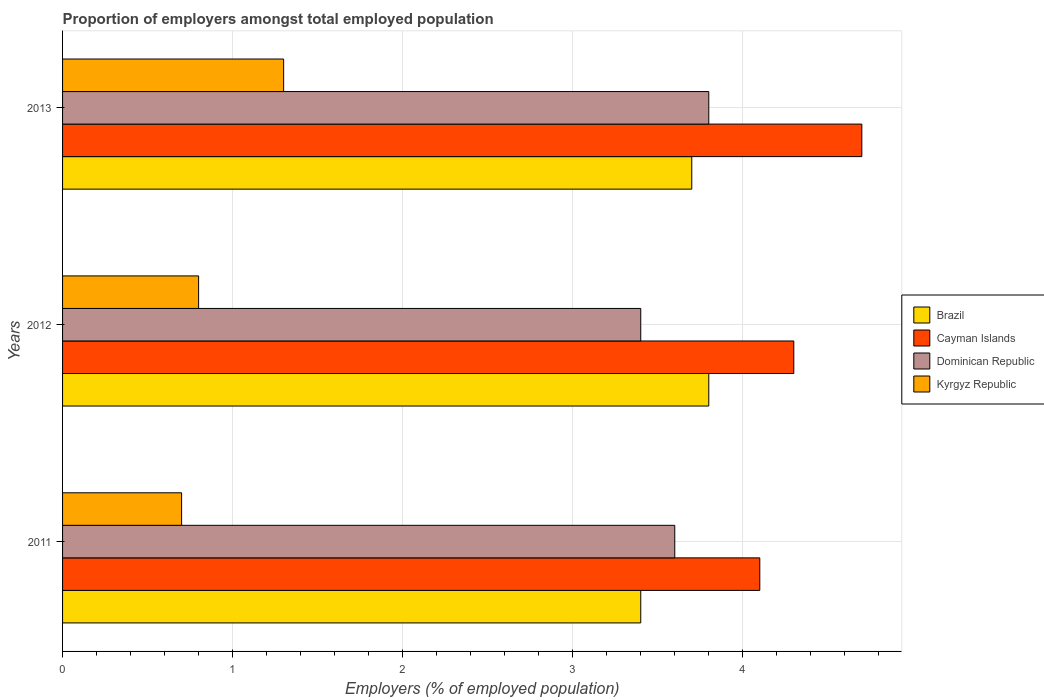How many bars are there on the 2nd tick from the top?
Keep it short and to the point. 4. How many bars are there on the 1st tick from the bottom?
Provide a succinct answer. 4. What is the label of the 1st group of bars from the top?
Your answer should be very brief. 2013. What is the proportion of employers in Dominican Republic in 2012?
Your answer should be very brief. 3.4. Across all years, what is the maximum proportion of employers in Brazil?
Your answer should be very brief. 3.8. Across all years, what is the minimum proportion of employers in Kyrgyz Republic?
Provide a succinct answer. 0.7. In which year was the proportion of employers in Cayman Islands maximum?
Make the answer very short. 2013. What is the total proportion of employers in Dominican Republic in the graph?
Your answer should be compact. 10.8. What is the difference between the proportion of employers in Dominican Republic in 2012 and that in 2013?
Offer a very short reply. -0.4. What is the difference between the proportion of employers in Brazil in 2011 and the proportion of employers in Cayman Islands in 2013?
Offer a terse response. -1.3. What is the average proportion of employers in Cayman Islands per year?
Ensure brevity in your answer.  4.37. In the year 2013, what is the difference between the proportion of employers in Brazil and proportion of employers in Kyrgyz Republic?
Your response must be concise. 2.4. What is the ratio of the proportion of employers in Kyrgyz Republic in 2011 to that in 2013?
Offer a terse response. 0.54. Is the difference between the proportion of employers in Brazil in 2011 and 2013 greater than the difference between the proportion of employers in Kyrgyz Republic in 2011 and 2013?
Offer a terse response. Yes. What is the difference between the highest and the second highest proportion of employers in Kyrgyz Republic?
Provide a succinct answer. 0.5. What is the difference between the highest and the lowest proportion of employers in Dominican Republic?
Keep it short and to the point. 0.4. In how many years, is the proportion of employers in Brazil greater than the average proportion of employers in Brazil taken over all years?
Offer a terse response. 2. What does the 3rd bar from the top in 2012 represents?
Ensure brevity in your answer.  Cayman Islands. What does the 2nd bar from the bottom in 2013 represents?
Your answer should be very brief. Cayman Islands. Is it the case that in every year, the sum of the proportion of employers in Dominican Republic and proportion of employers in Brazil is greater than the proportion of employers in Kyrgyz Republic?
Your answer should be very brief. Yes. Are all the bars in the graph horizontal?
Offer a very short reply. Yes. Are the values on the major ticks of X-axis written in scientific E-notation?
Your answer should be compact. No. Does the graph contain grids?
Make the answer very short. Yes. How many legend labels are there?
Provide a short and direct response. 4. How are the legend labels stacked?
Keep it short and to the point. Vertical. What is the title of the graph?
Your response must be concise. Proportion of employers amongst total employed population. Does "Monaco" appear as one of the legend labels in the graph?
Your answer should be very brief. No. What is the label or title of the X-axis?
Provide a succinct answer. Employers (% of employed population). What is the label or title of the Y-axis?
Make the answer very short. Years. What is the Employers (% of employed population) of Brazil in 2011?
Your response must be concise. 3.4. What is the Employers (% of employed population) of Cayman Islands in 2011?
Your answer should be compact. 4.1. What is the Employers (% of employed population) of Dominican Republic in 2011?
Your answer should be compact. 3.6. What is the Employers (% of employed population) of Kyrgyz Republic in 2011?
Offer a terse response. 0.7. What is the Employers (% of employed population) of Brazil in 2012?
Keep it short and to the point. 3.8. What is the Employers (% of employed population) in Cayman Islands in 2012?
Ensure brevity in your answer.  4.3. What is the Employers (% of employed population) of Dominican Republic in 2012?
Provide a short and direct response. 3.4. What is the Employers (% of employed population) in Kyrgyz Republic in 2012?
Give a very brief answer. 0.8. What is the Employers (% of employed population) in Brazil in 2013?
Your answer should be very brief. 3.7. What is the Employers (% of employed population) in Cayman Islands in 2013?
Your answer should be compact. 4.7. What is the Employers (% of employed population) of Dominican Republic in 2013?
Provide a short and direct response. 3.8. What is the Employers (% of employed population) in Kyrgyz Republic in 2013?
Provide a short and direct response. 1.3. Across all years, what is the maximum Employers (% of employed population) of Brazil?
Provide a short and direct response. 3.8. Across all years, what is the maximum Employers (% of employed population) in Cayman Islands?
Offer a terse response. 4.7. Across all years, what is the maximum Employers (% of employed population) of Dominican Republic?
Keep it short and to the point. 3.8. Across all years, what is the maximum Employers (% of employed population) in Kyrgyz Republic?
Provide a succinct answer. 1.3. Across all years, what is the minimum Employers (% of employed population) of Brazil?
Provide a short and direct response. 3.4. Across all years, what is the minimum Employers (% of employed population) of Cayman Islands?
Your answer should be very brief. 4.1. Across all years, what is the minimum Employers (% of employed population) of Dominican Republic?
Provide a succinct answer. 3.4. Across all years, what is the minimum Employers (% of employed population) of Kyrgyz Republic?
Ensure brevity in your answer.  0.7. What is the total Employers (% of employed population) of Cayman Islands in the graph?
Give a very brief answer. 13.1. What is the total Employers (% of employed population) of Dominican Republic in the graph?
Your response must be concise. 10.8. What is the difference between the Employers (% of employed population) in Brazil in 2011 and that in 2012?
Your answer should be very brief. -0.4. What is the difference between the Employers (% of employed population) in Cayman Islands in 2011 and that in 2012?
Your answer should be very brief. -0.2. What is the difference between the Employers (% of employed population) in Brazil in 2011 and that in 2013?
Offer a very short reply. -0.3. What is the difference between the Employers (% of employed population) in Kyrgyz Republic in 2012 and that in 2013?
Offer a very short reply. -0.5. What is the difference between the Employers (% of employed population) in Brazil in 2011 and the Employers (% of employed population) in Cayman Islands in 2012?
Provide a short and direct response. -0.9. What is the difference between the Employers (% of employed population) of Brazil in 2011 and the Employers (% of employed population) of Dominican Republic in 2012?
Offer a terse response. 0. What is the difference between the Employers (% of employed population) in Brazil in 2011 and the Employers (% of employed population) in Kyrgyz Republic in 2012?
Your response must be concise. 2.6. What is the difference between the Employers (% of employed population) of Cayman Islands in 2011 and the Employers (% of employed population) of Kyrgyz Republic in 2012?
Keep it short and to the point. 3.3. What is the difference between the Employers (% of employed population) in Brazil in 2011 and the Employers (% of employed population) in Kyrgyz Republic in 2013?
Your answer should be compact. 2.1. What is the difference between the Employers (% of employed population) in Cayman Islands in 2011 and the Employers (% of employed population) in Kyrgyz Republic in 2013?
Offer a terse response. 2.8. What is the difference between the Employers (% of employed population) in Dominican Republic in 2011 and the Employers (% of employed population) in Kyrgyz Republic in 2013?
Give a very brief answer. 2.3. What is the difference between the Employers (% of employed population) in Brazil in 2012 and the Employers (% of employed population) in Kyrgyz Republic in 2013?
Provide a succinct answer. 2.5. What is the difference between the Employers (% of employed population) of Cayman Islands in 2012 and the Employers (% of employed population) of Dominican Republic in 2013?
Your answer should be very brief. 0.5. What is the average Employers (% of employed population) in Brazil per year?
Provide a short and direct response. 3.63. What is the average Employers (% of employed population) of Cayman Islands per year?
Offer a very short reply. 4.37. In the year 2011, what is the difference between the Employers (% of employed population) in Cayman Islands and Employers (% of employed population) in Dominican Republic?
Your answer should be very brief. 0.5. In the year 2012, what is the difference between the Employers (% of employed population) in Brazil and Employers (% of employed population) in Kyrgyz Republic?
Provide a short and direct response. 3. In the year 2012, what is the difference between the Employers (% of employed population) of Cayman Islands and Employers (% of employed population) of Kyrgyz Republic?
Keep it short and to the point. 3.5. In the year 2012, what is the difference between the Employers (% of employed population) in Dominican Republic and Employers (% of employed population) in Kyrgyz Republic?
Offer a very short reply. 2.6. In the year 2013, what is the difference between the Employers (% of employed population) of Cayman Islands and Employers (% of employed population) of Dominican Republic?
Give a very brief answer. 0.9. In the year 2013, what is the difference between the Employers (% of employed population) of Cayman Islands and Employers (% of employed population) of Kyrgyz Republic?
Ensure brevity in your answer.  3.4. What is the ratio of the Employers (% of employed population) in Brazil in 2011 to that in 2012?
Offer a terse response. 0.89. What is the ratio of the Employers (% of employed population) in Cayman Islands in 2011 to that in 2012?
Provide a short and direct response. 0.95. What is the ratio of the Employers (% of employed population) of Dominican Republic in 2011 to that in 2012?
Provide a short and direct response. 1.06. What is the ratio of the Employers (% of employed population) in Brazil in 2011 to that in 2013?
Keep it short and to the point. 0.92. What is the ratio of the Employers (% of employed population) of Cayman Islands in 2011 to that in 2013?
Your answer should be very brief. 0.87. What is the ratio of the Employers (% of employed population) of Dominican Republic in 2011 to that in 2013?
Make the answer very short. 0.95. What is the ratio of the Employers (% of employed population) in Kyrgyz Republic in 2011 to that in 2013?
Your response must be concise. 0.54. What is the ratio of the Employers (% of employed population) of Cayman Islands in 2012 to that in 2013?
Provide a succinct answer. 0.91. What is the ratio of the Employers (% of employed population) of Dominican Republic in 2012 to that in 2013?
Provide a succinct answer. 0.89. What is the ratio of the Employers (% of employed population) of Kyrgyz Republic in 2012 to that in 2013?
Your answer should be very brief. 0.62. What is the difference between the highest and the second highest Employers (% of employed population) in Brazil?
Provide a succinct answer. 0.1. What is the difference between the highest and the lowest Employers (% of employed population) in Cayman Islands?
Provide a succinct answer. 0.6. What is the difference between the highest and the lowest Employers (% of employed population) of Dominican Republic?
Provide a succinct answer. 0.4. What is the difference between the highest and the lowest Employers (% of employed population) of Kyrgyz Republic?
Give a very brief answer. 0.6. 